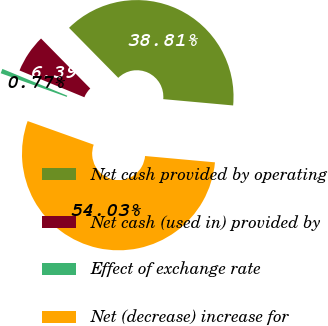Convert chart to OTSL. <chart><loc_0><loc_0><loc_500><loc_500><pie_chart><fcel>Net cash provided by operating<fcel>Net cash (used in) provided by<fcel>Effect of exchange rate<fcel>Net (decrease) increase for<nl><fcel>38.81%<fcel>6.39%<fcel>0.77%<fcel>54.03%<nl></chart> 